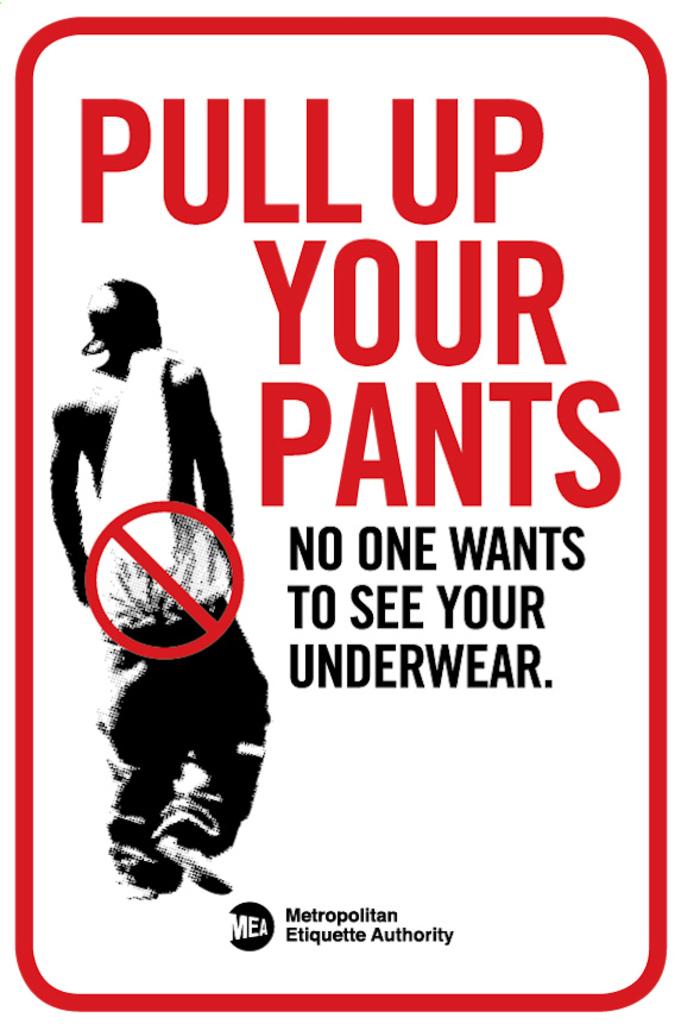Pull up your what?
Give a very brief answer. Pants. What is the sign asking us to pull up?
Provide a short and direct response. Pants. 